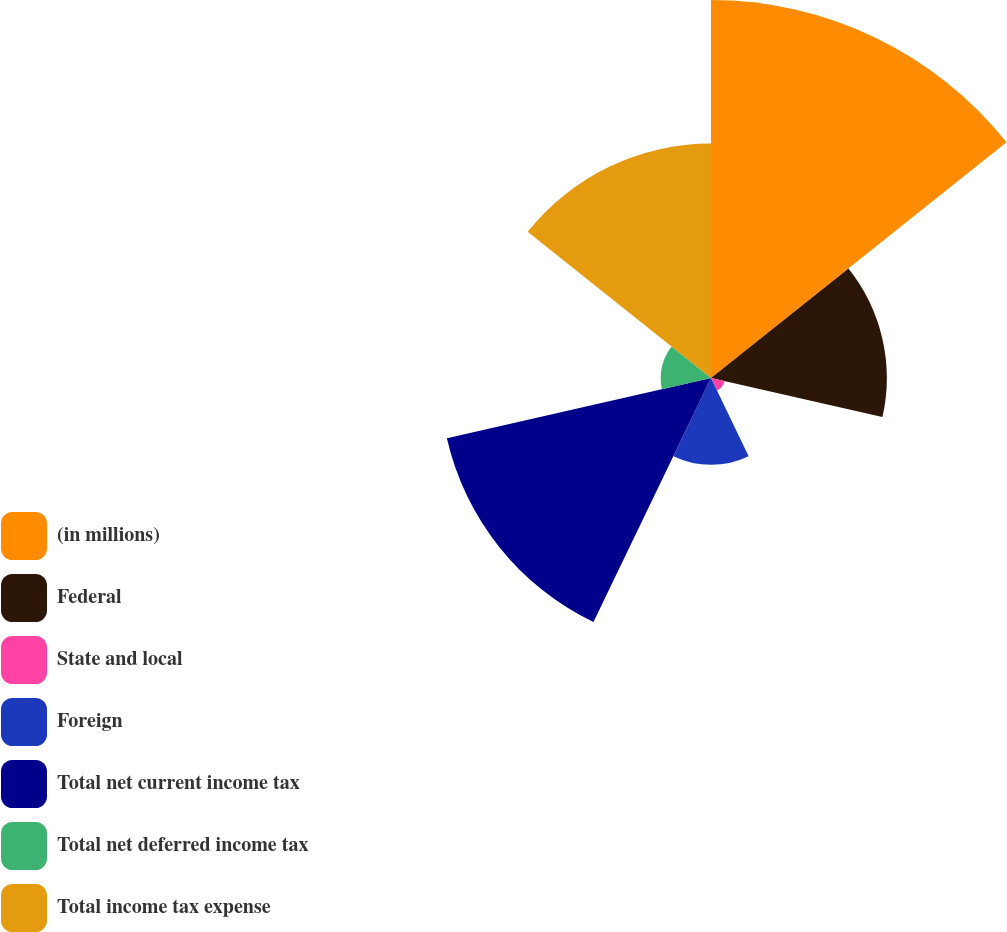Convert chart to OTSL. <chart><loc_0><loc_0><loc_500><loc_500><pie_chart><fcel>(in millions)<fcel>Federal<fcel>State and local<fcel>Foreign<fcel>Total net current income tax<fcel>Total net deferred income tax<fcel>Total income tax expense<nl><fcel>31.24%<fcel>14.53%<fcel>1.15%<fcel>7.17%<fcel>22.39%<fcel>4.16%<fcel>19.38%<nl></chart> 